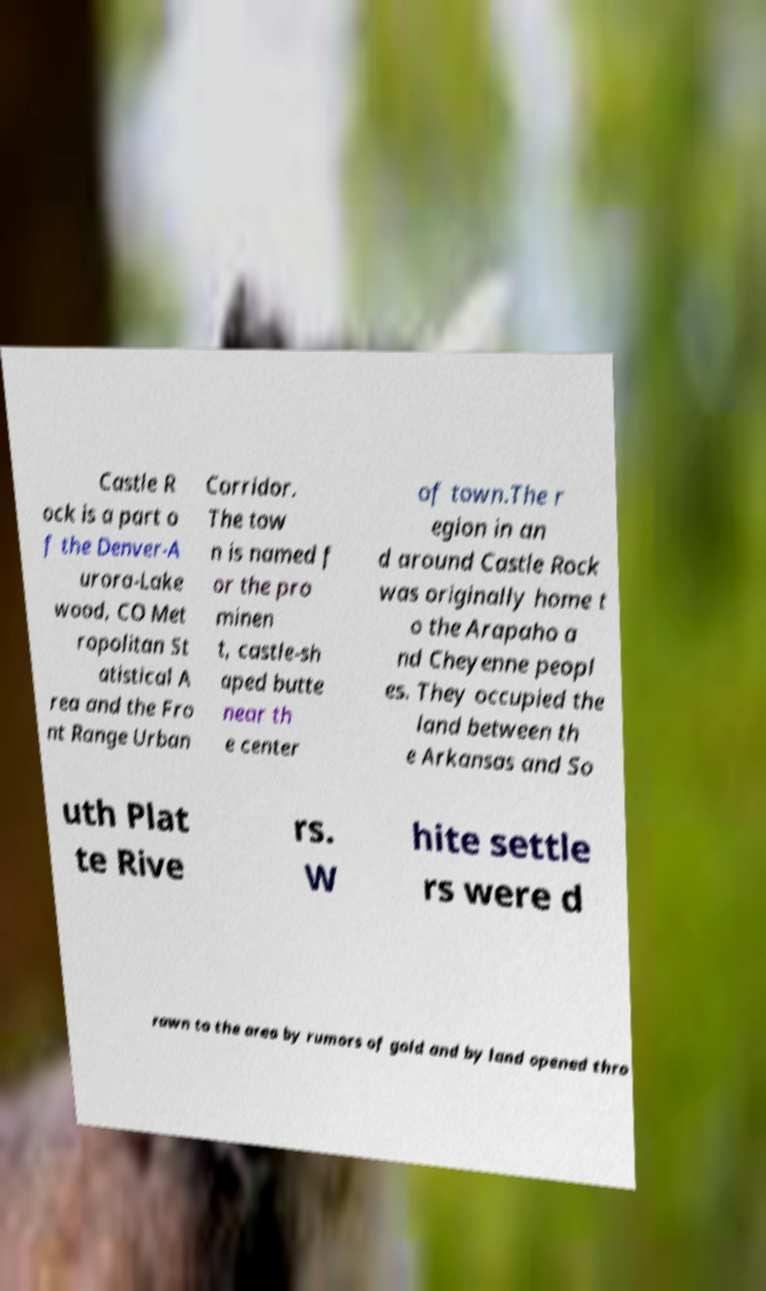Could you extract and type out the text from this image? Castle R ock is a part o f the Denver-A urora-Lake wood, CO Met ropolitan St atistical A rea and the Fro nt Range Urban Corridor. The tow n is named f or the pro minen t, castle-sh aped butte near th e center of town.The r egion in an d around Castle Rock was originally home t o the Arapaho a nd Cheyenne peopl es. They occupied the land between th e Arkansas and So uth Plat te Rive rs. W hite settle rs were d rawn to the area by rumors of gold and by land opened thro 